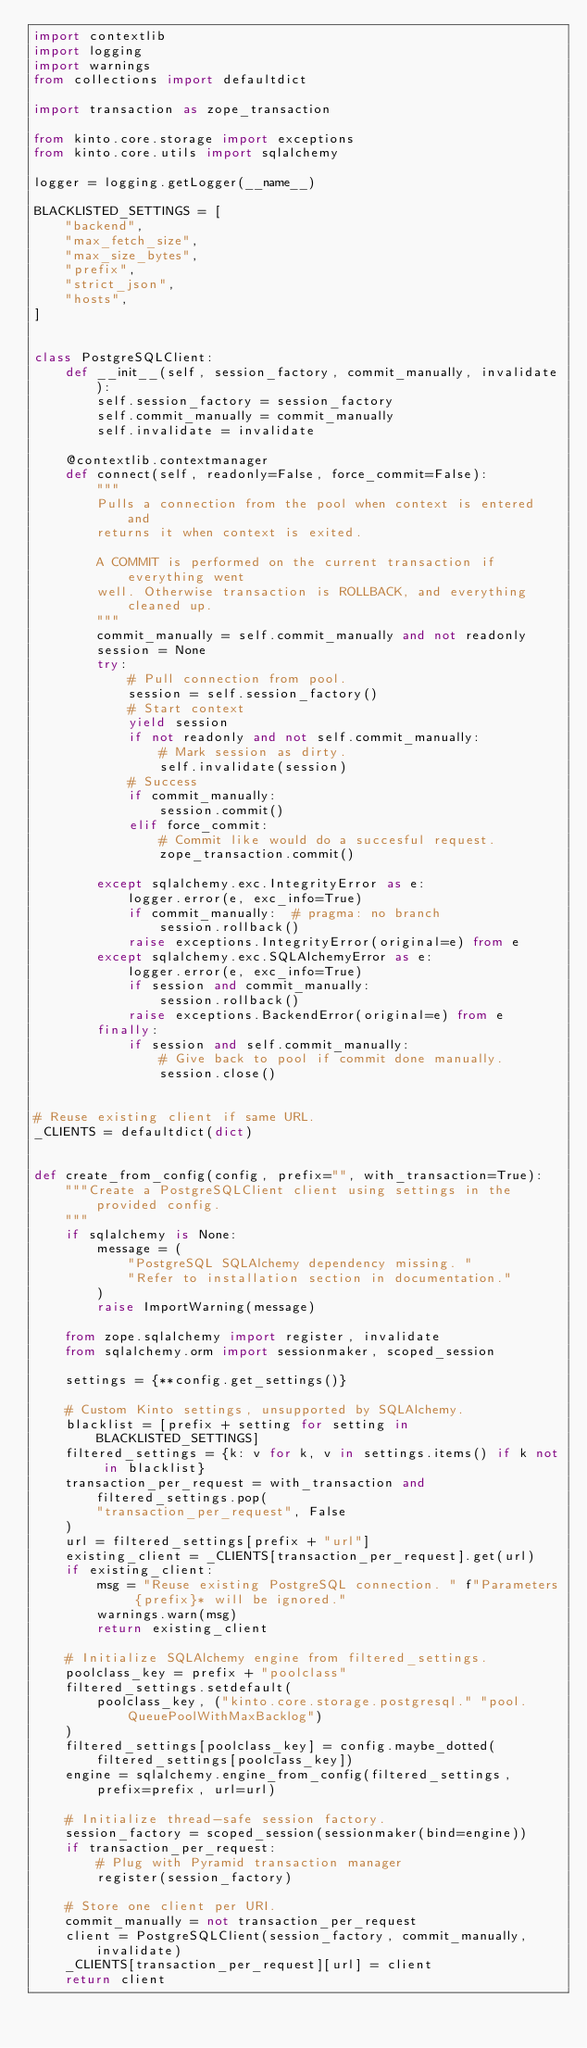Convert code to text. <code><loc_0><loc_0><loc_500><loc_500><_Python_>import contextlib
import logging
import warnings
from collections import defaultdict

import transaction as zope_transaction

from kinto.core.storage import exceptions
from kinto.core.utils import sqlalchemy

logger = logging.getLogger(__name__)

BLACKLISTED_SETTINGS = [
    "backend",
    "max_fetch_size",
    "max_size_bytes",
    "prefix",
    "strict_json",
    "hosts",
]


class PostgreSQLClient:
    def __init__(self, session_factory, commit_manually, invalidate):
        self.session_factory = session_factory
        self.commit_manually = commit_manually
        self.invalidate = invalidate

    @contextlib.contextmanager
    def connect(self, readonly=False, force_commit=False):
        """
        Pulls a connection from the pool when context is entered and
        returns it when context is exited.

        A COMMIT is performed on the current transaction if everything went
        well. Otherwise transaction is ROLLBACK, and everything cleaned up.
        """
        commit_manually = self.commit_manually and not readonly
        session = None
        try:
            # Pull connection from pool.
            session = self.session_factory()
            # Start context
            yield session
            if not readonly and not self.commit_manually:
                # Mark session as dirty.
                self.invalidate(session)
            # Success
            if commit_manually:
                session.commit()
            elif force_commit:
                # Commit like would do a succesful request.
                zope_transaction.commit()

        except sqlalchemy.exc.IntegrityError as e:
            logger.error(e, exc_info=True)
            if commit_manually:  # pragma: no branch
                session.rollback()
            raise exceptions.IntegrityError(original=e) from e
        except sqlalchemy.exc.SQLAlchemyError as e:
            logger.error(e, exc_info=True)
            if session and commit_manually:
                session.rollback()
            raise exceptions.BackendError(original=e) from e
        finally:
            if session and self.commit_manually:
                # Give back to pool if commit done manually.
                session.close()


# Reuse existing client if same URL.
_CLIENTS = defaultdict(dict)


def create_from_config(config, prefix="", with_transaction=True):
    """Create a PostgreSQLClient client using settings in the provided config.
    """
    if sqlalchemy is None:
        message = (
            "PostgreSQL SQLAlchemy dependency missing. "
            "Refer to installation section in documentation."
        )
        raise ImportWarning(message)

    from zope.sqlalchemy import register, invalidate
    from sqlalchemy.orm import sessionmaker, scoped_session

    settings = {**config.get_settings()}

    # Custom Kinto settings, unsupported by SQLAlchemy.
    blacklist = [prefix + setting for setting in BLACKLISTED_SETTINGS]
    filtered_settings = {k: v for k, v in settings.items() if k not in blacklist}
    transaction_per_request = with_transaction and filtered_settings.pop(
        "transaction_per_request", False
    )
    url = filtered_settings[prefix + "url"]
    existing_client = _CLIENTS[transaction_per_request].get(url)
    if existing_client:
        msg = "Reuse existing PostgreSQL connection. " f"Parameters {prefix}* will be ignored."
        warnings.warn(msg)
        return existing_client

    # Initialize SQLAlchemy engine from filtered_settings.
    poolclass_key = prefix + "poolclass"
    filtered_settings.setdefault(
        poolclass_key, ("kinto.core.storage.postgresql." "pool.QueuePoolWithMaxBacklog")
    )
    filtered_settings[poolclass_key] = config.maybe_dotted(filtered_settings[poolclass_key])
    engine = sqlalchemy.engine_from_config(filtered_settings, prefix=prefix, url=url)

    # Initialize thread-safe session factory.
    session_factory = scoped_session(sessionmaker(bind=engine))
    if transaction_per_request:
        # Plug with Pyramid transaction manager
        register(session_factory)

    # Store one client per URI.
    commit_manually = not transaction_per_request
    client = PostgreSQLClient(session_factory, commit_manually, invalidate)
    _CLIENTS[transaction_per_request][url] = client
    return client
</code> 